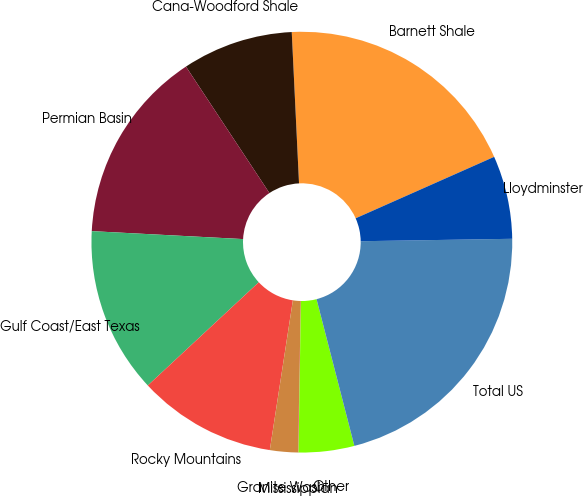Convert chart to OTSL. <chart><loc_0><loc_0><loc_500><loc_500><pie_chart><fcel>Barnett Shale<fcel>Cana-Woodford Shale<fcel>Permian Basin<fcel>Gulf Coast/East Texas<fcel>Rocky Mountains<fcel>Granite Wash<fcel>Mississippian<fcel>Other<fcel>Total US<fcel>Lloydminster<nl><fcel>19.12%<fcel>8.52%<fcel>14.88%<fcel>12.76%<fcel>10.64%<fcel>2.15%<fcel>0.03%<fcel>4.27%<fcel>21.24%<fcel>6.39%<nl></chart> 